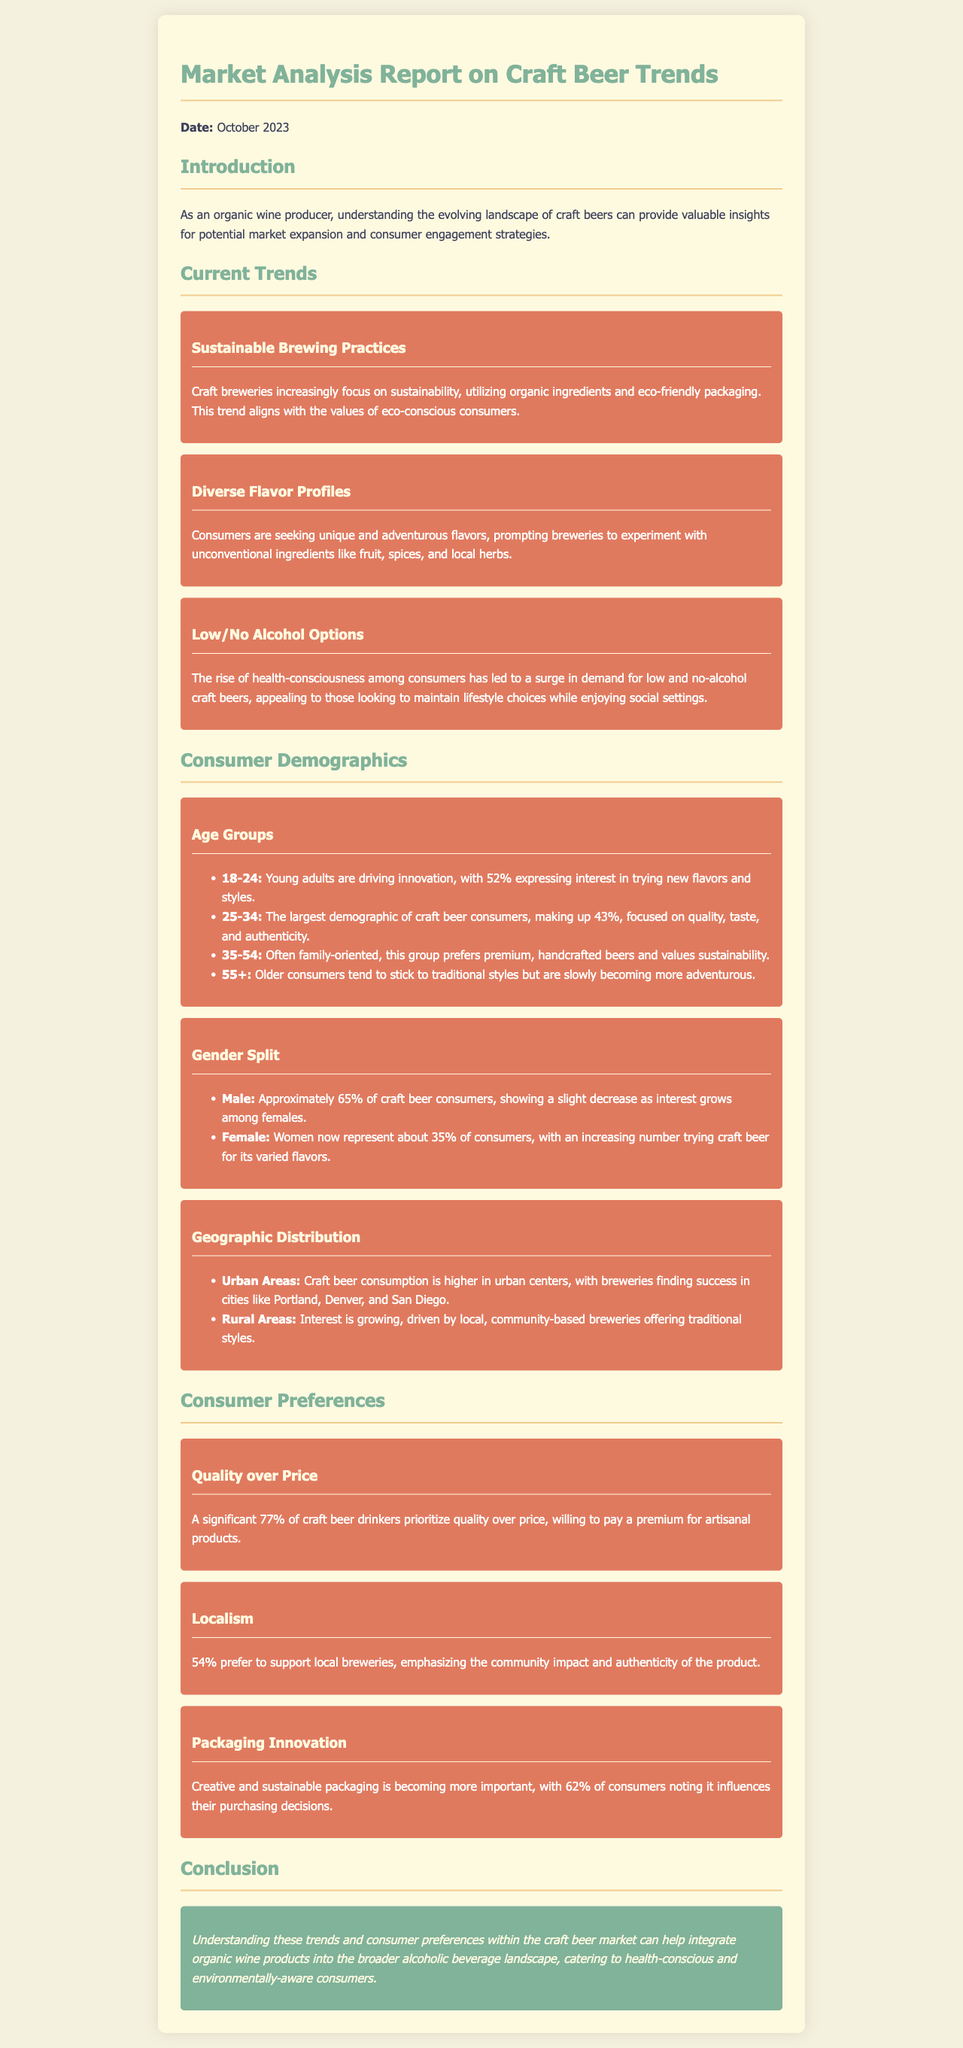What is the date of the report? The date of the report is mentioned in the introduction section.
Answer: October 2023 What percentage of consumers prioritize quality over price? This percentage is specified in the consumer preferences section.
Answer: 77% Which demographic makes up the largest percentage of craft beer consumers? The demographic with the highest percentage is stated in the age groups section.
Answer: 25-34 What key trend focuses on utilizing organic ingredients? The trend emphasizing eco-friendly practices is highlighted in the current trends section.
Answer: Sustainable Brewing Practices What is the percentage of urban areas in craft beer consumption? The document indicates that urban areas have higher consumption, but does not provide a specific percentage.
Answer: Higher consumption What is a consumer preference regarding local breweries? The document notes a specific consumer preference towards local breweries in the consumer preferences section.
Answer: 54% Which age group expresses interest in trying new flavors? The age group expressing this interest is mentioned in the age groups section.
Answer: 18-24 What factor influences 62% of consumers' purchasing decisions? This influence is discussed in the consumer preferences section under packaging.
Answer: Packaging Innovation What type of consumers is driving the innovation in craft beer? The demographic responsible for pushing innovation is specified in the age groups section.
Answer: Young adults 